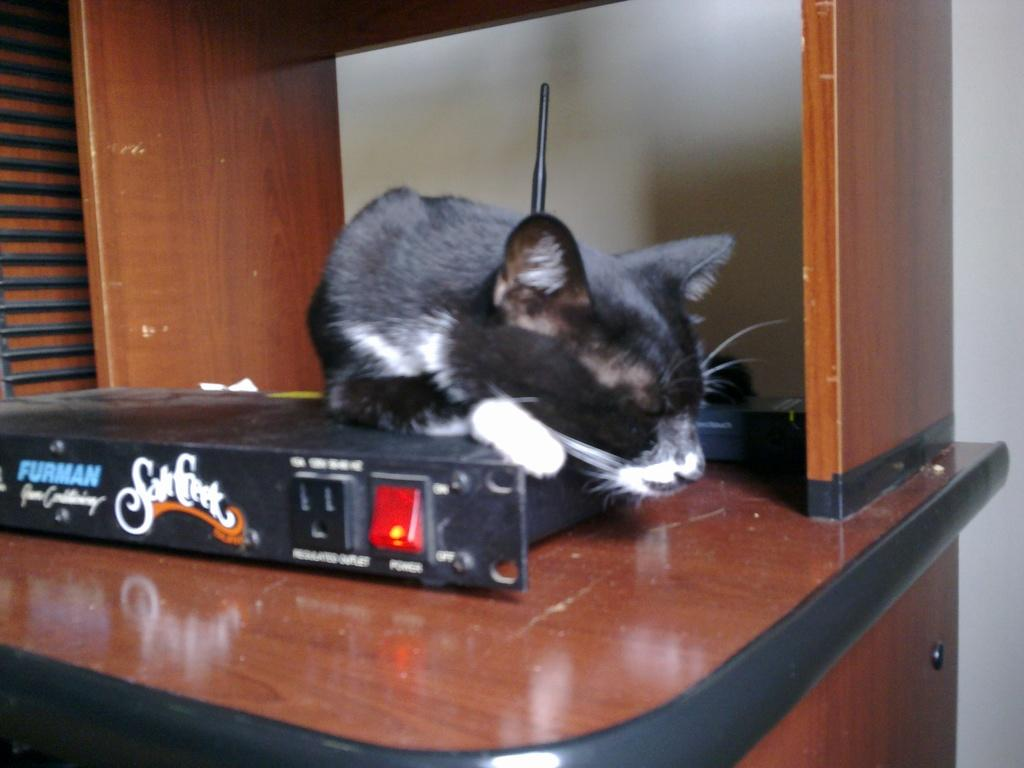What object is present in the image that is not a living creature? There is a box in the image. What is on top of the box? There is a rat on the box. Can you describe the rat's appearance? The rat is black. What might the box be used for? The box appears to be an antenna box. What type of knife is the rat using to cut the salt in the image? There is no knife or salt present in the image; it features a black rat on a box. 